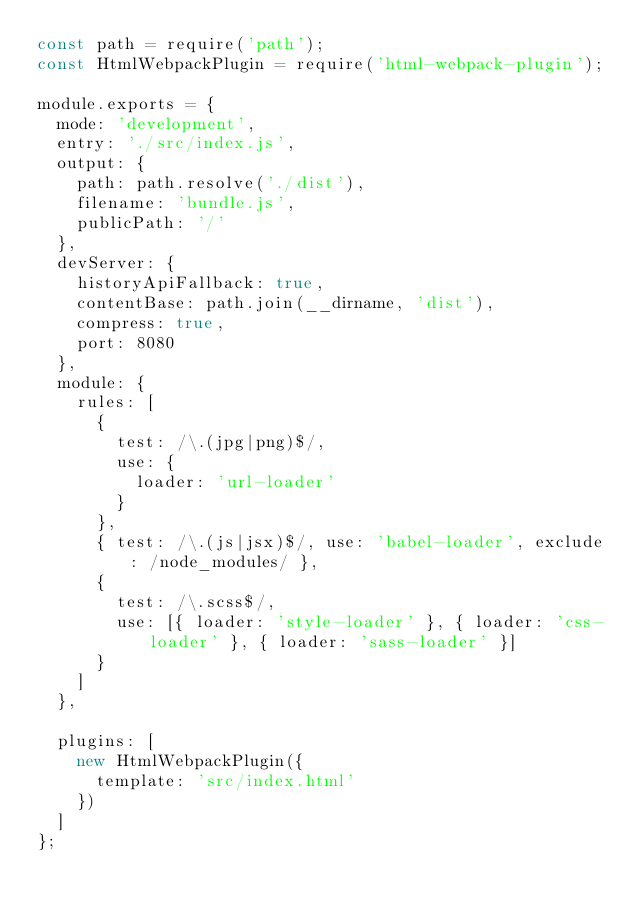Convert code to text. <code><loc_0><loc_0><loc_500><loc_500><_JavaScript_>const path = require('path');
const HtmlWebpackPlugin = require('html-webpack-plugin');

module.exports = {
  mode: 'development',
  entry: './src/index.js',
  output: {
    path: path.resolve('./dist'),
    filename: 'bundle.js',
    publicPath: '/'
  },
  devServer: {
    historyApiFallback: true,
    contentBase: path.join(__dirname, 'dist'),
    compress: true,
    port: 8080
  },
  module: {
    rules: [
      {
        test: /\.(jpg|png)$/,
        use: {
          loader: 'url-loader'
        }
      },
      { test: /\.(js|jsx)$/, use: 'babel-loader', exclude: /node_modules/ },
      {
        test: /\.scss$/,
        use: [{ loader: 'style-loader' }, { loader: 'css-loader' }, { loader: 'sass-loader' }]
      }
    ]
  },

  plugins: [
    new HtmlWebpackPlugin({
      template: 'src/index.html'
    })
  ]
};
</code> 